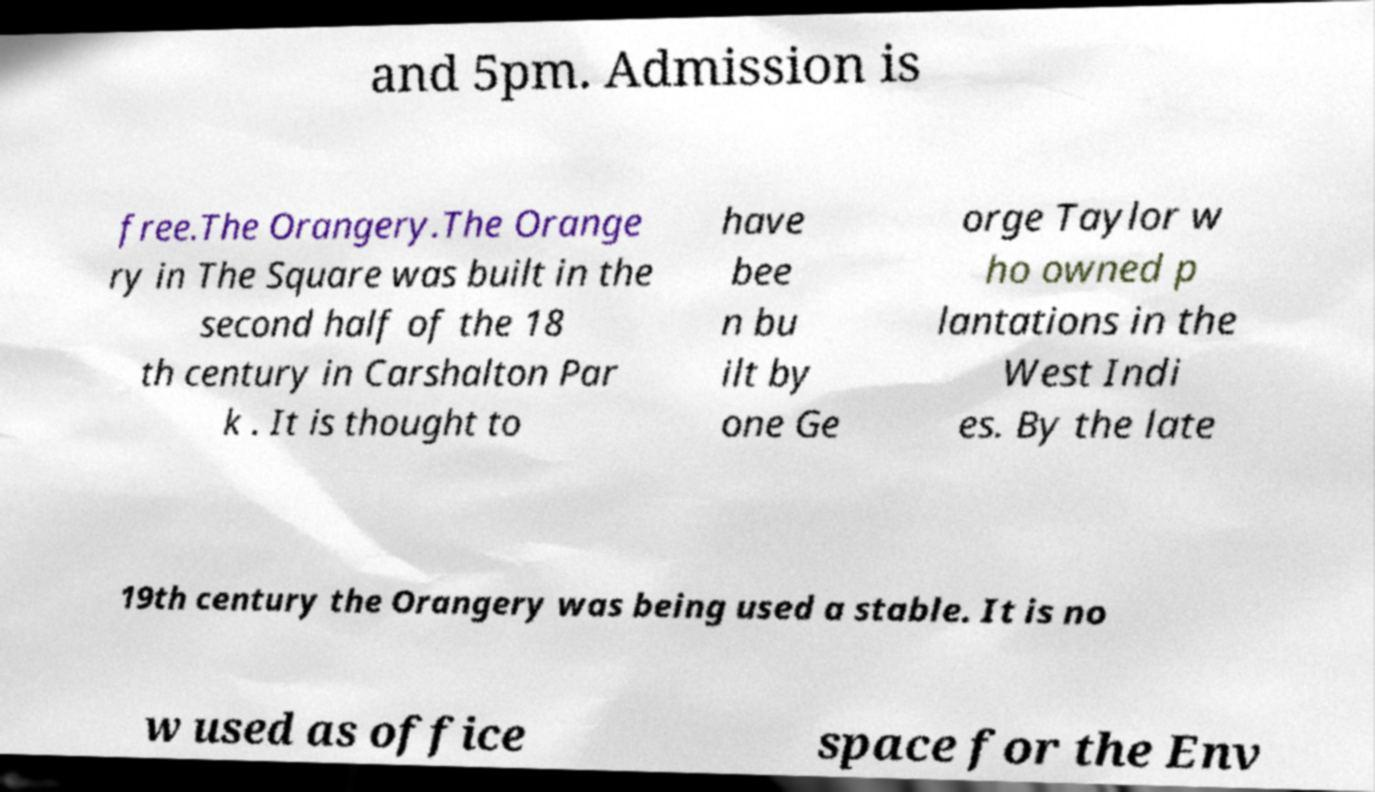Can you read and provide the text displayed in the image?This photo seems to have some interesting text. Can you extract and type it out for me? and 5pm. Admission is free.The Orangery.The Orange ry in The Square was built in the second half of the 18 th century in Carshalton Par k . It is thought to have bee n bu ilt by one Ge orge Taylor w ho owned p lantations in the West Indi es. By the late 19th century the Orangery was being used a stable. It is no w used as office space for the Env 